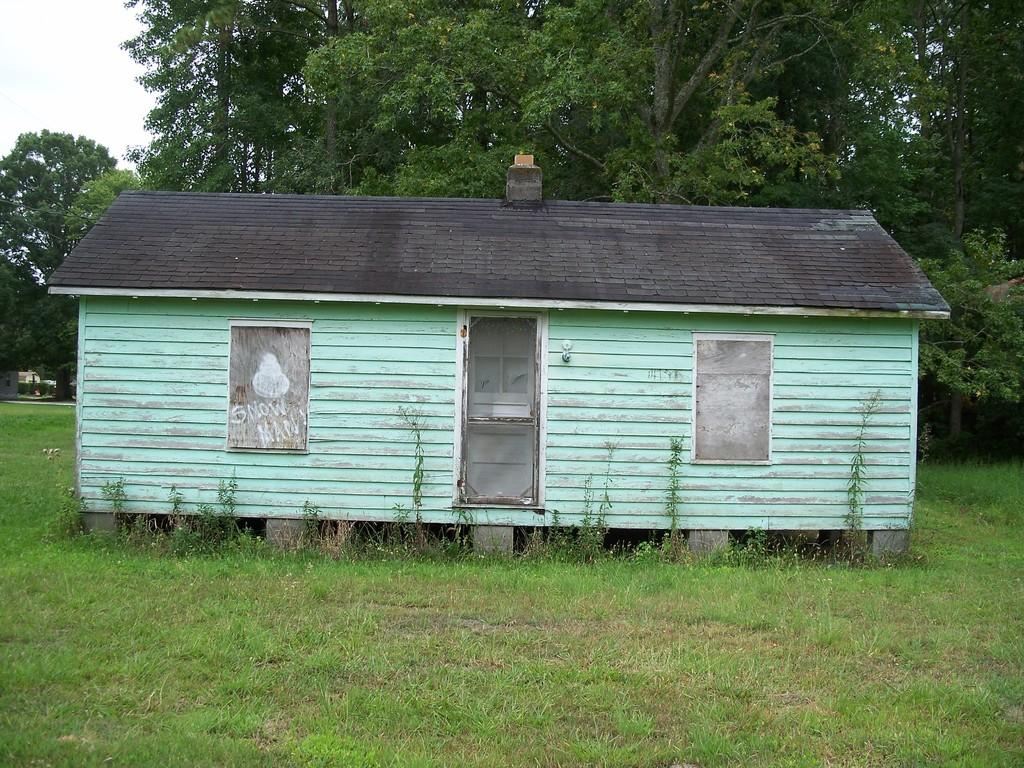What type of house is in the image? There is a wooden house in the image. What can be seen in the background of the image? There is grass, trees, and the sky visible in the background of the image. What type of haircut does the wooden house have in the image? The wooden house does not have a haircut, as it is an inanimate object and cannot have a haircut. 